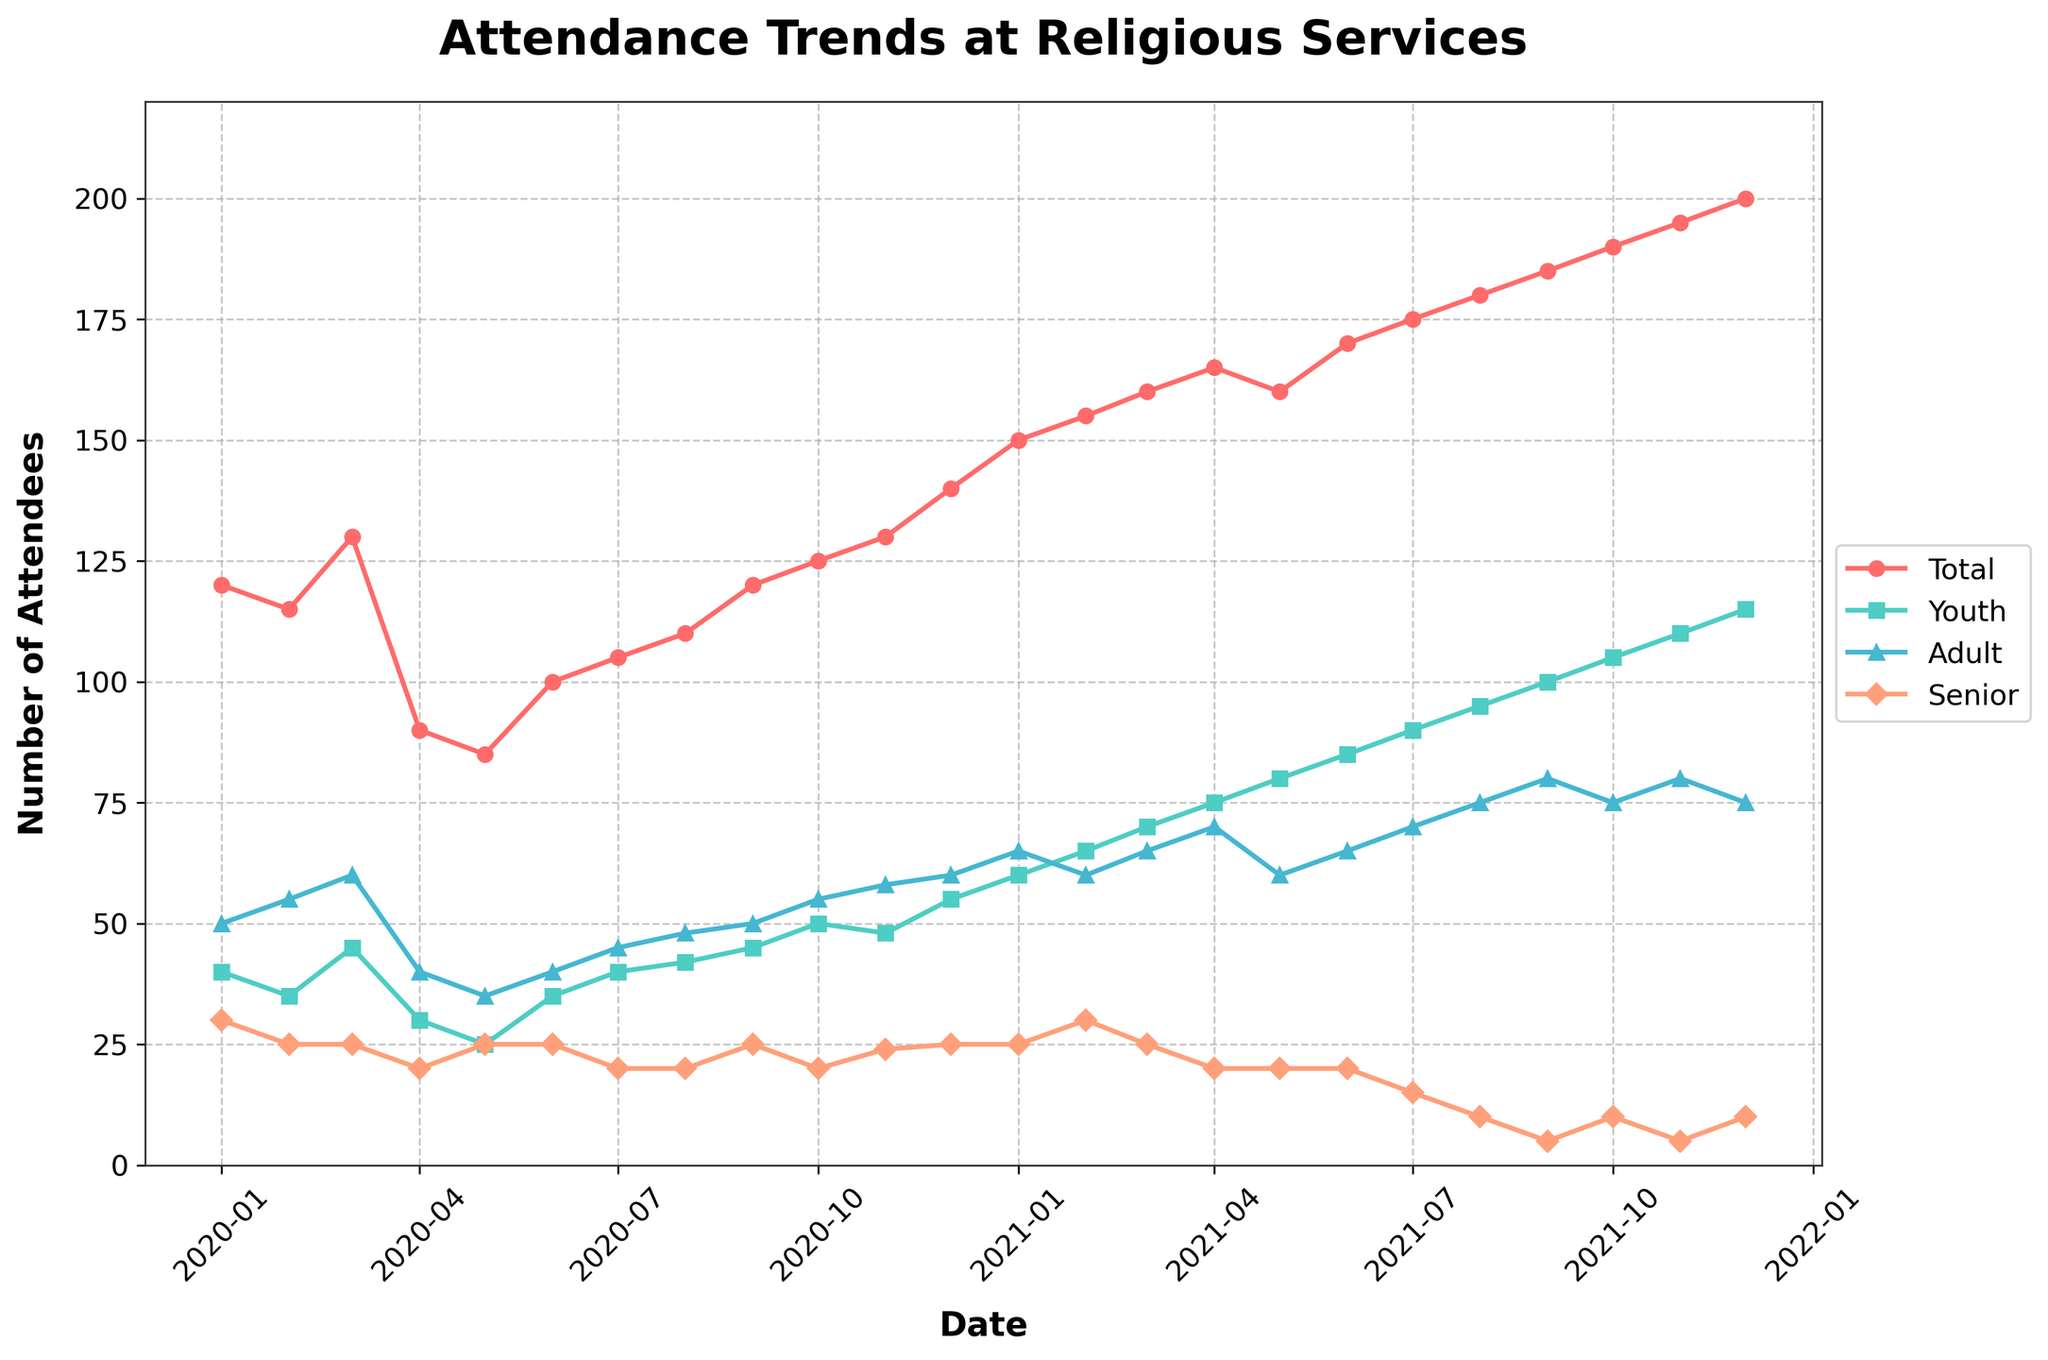What is the title of the plot? The title of the plot is placed at the top center of the figure and is often the largest text. It reads: "Attendance Trends at Religious Services".
Answer: Attendance Trends at Religious Services What is the range of dates shown on the x-axis? The x-axis labels show dates starting from "2020-01" on the left to "2021-12" on the right.
Answer: 2020-01 to 2021-12 Which group had the highest attendance in December 2020? Follow the data points for December 2020. The plot shows that the "Youth Attendance" had the highest value, marked by the shape and color associated with youth attendees.
Answer: Youth Attendance Did the total attendance ever drop below 100? Observe the line depicting the total attendance. During some months in the middle of 2020, the line dips below 100. For example, in April and May 2020.
Answer: Yes What color represents "Senior Attendance"? Identify the color used for the line and markers representing "Senior Attendance". It's a peach-colored line with diamond-shaped markers.
Answer: Peach Which category shows a consistently increasing trend over the entire period? Observe the slopes of the lines. "Youth Attendance" shows a generally steady increase from January 2020 to December 2021.
Answer: Youth Attendance How many data points are there for each line? Count the number of data points for any line. Since time is monthly from January 2020 to December 2021, each line will have 24 data points.
Answer: 24 What is the average attendance for adults throughout the entire period? Add all the "Adult Attendance" numbers and divide by the number of months (24). Calculation: (50+55+60+...+75)/24.
Answer: 60 In which month was the lowest attendance for youth recorded? Follow the line for "Youth Attendance" and find the lowest point, marked by the lowest value in this line. This occurs in May 2020.
Answer: May 2020 What is the difference between the highest and lowest total attendance values? Identify the highest and lowest points on the "Total Attendance" line. The highest is 200 in December 2021 and the lowest is 85 in May 2020. The difference is 200 - 85.
Answer: 115 